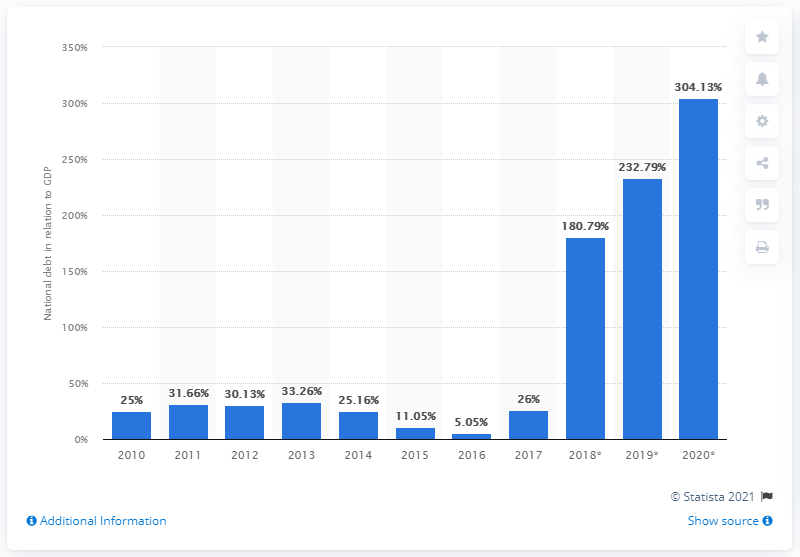List a handful of essential elements in this visual. In 2017, Venezuela's national debt accounted for approximately 26% of the country's Gross Domestic Product (GDP). 